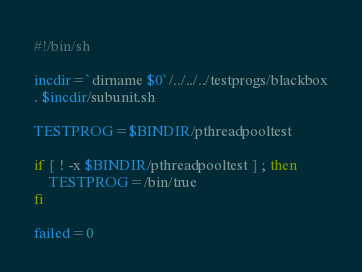Convert code to text. <code><loc_0><loc_0><loc_500><loc_500><_Bash_>#!/bin/sh

incdir=`dirname $0`/../../../testprogs/blackbox
. $incdir/subunit.sh

TESTPROG=$BINDIR/pthreadpooltest

if [ ! -x $BINDIR/pthreadpooltest ] ; then
    TESTPROG=/bin/true
fi

failed=0
</code> 